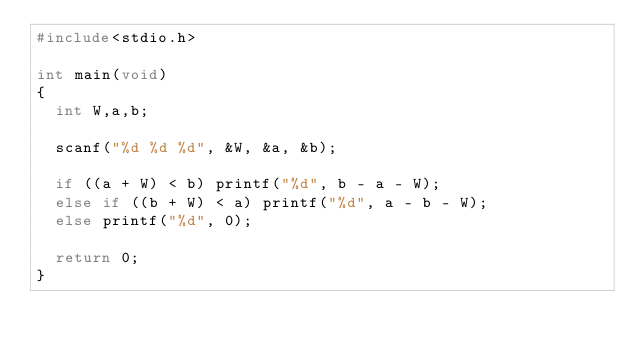<code> <loc_0><loc_0><loc_500><loc_500><_C_>#include<stdio.h>

int main(void)
{
	int W,a,b;

	scanf("%d %d %d", &W, &a, &b);

	if ((a + W) < b) printf("%d", b - a - W);
	else if ((b + W) < a) printf("%d", a - b - W);
	else printf("%d", 0);

	return 0;
}</code> 